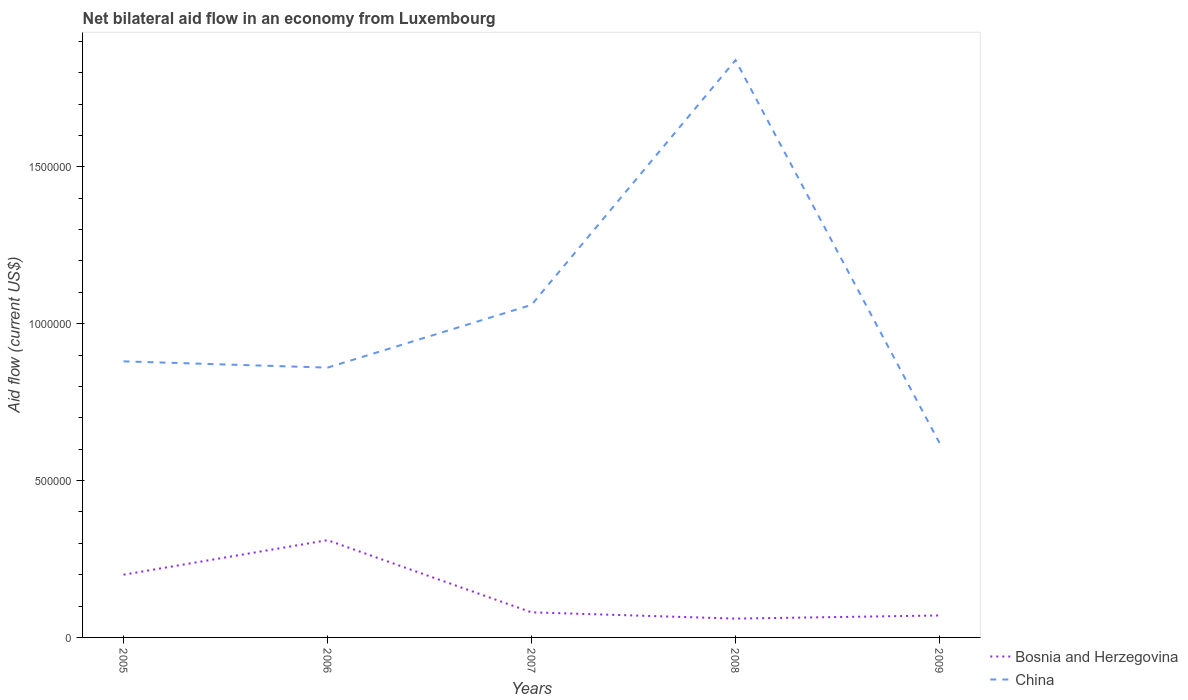How many different coloured lines are there?
Offer a terse response. 2. Across all years, what is the maximum net bilateral aid flow in China?
Your response must be concise. 6.20e+05. What is the total net bilateral aid flow in China in the graph?
Provide a short and direct response. 2.60e+05. What is the difference between the highest and the second highest net bilateral aid flow in Bosnia and Herzegovina?
Provide a succinct answer. 2.50e+05. How many lines are there?
Provide a succinct answer. 2. What is the difference between two consecutive major ticks on the Y-axis?
Make the answer very short. 5.00e+05. Are the values on the major ticks of Y-axis written in scientific E-notation?
Give a very brief answer. No. How are the legend labels stacked?
Offer a terse response. Vertical. What is the title of the graph?
Give a very brief answer. Net bilateral aid flow in an economy from Luxembourg. Does "Norway" appear as one of the legend labels in the graph?
Provide a short and direct response. No. What is the label or title of the X-axis?
Give a very brief answer. Years. What is the Aid flow (current US$) in China in 2005?
Keep it short and to the point. 8.80e+05. What is the Aid flow (current US$) of China in 2006?
Provide a short and direct response. 8.60e+05. What is the Aid flow (current US$) in Bosnia and Herzegovina in 2007?
Your response must be concise. 8.00e+04. What is the Aid flow (current US$) in China in 2007?
Offer a very short reply. 1.06e+06. What is the Aid flow (current US$) in China in 2008?
Your response must be concise. 1.84e+06. What is the Aid flow (current US$) in Bosnia and Herzegovina in 2009?
Provide a succinct answer. 7.00e+04. What is the Aid flow (current US$) of China in 2009?
Your answer should be very brief. 6.20e+05. Across all years, what is the maximum Aid flow (current US$) of Bosnia and Herzegovina?
Ensure brevity in your answer.  3.10e+05. Across all years, what is the maximum Aid flow (current US$) in China?
Your answer should be compact. 1.84e+06. Across all years, what is the minimum Aid flow (current US$) in Bosnia and Herzegovina?
Provide a succinct answer. 6.00e+04. Across all years, what is the minimum Aid flow (current US$) in China?
Offer a very short reply. 6.20e+05. What is the total Aid flow (current US$) of Bosnia and Herzegovina in the graph?
Give a very brief answer. 7.20e+05. What is the total Aid flow (current US$) of China in the graph?
Your answer should be very brief. 5.26e+06. What is the difference between the Aid flow (current US$) in Bosnia and Herzegovina in 2005 and that in 2008?
Give a very brief answer. 1.40e+05. What is the difference between the Aid flow (current US$) in China in 2005 and that in 2008?
Provide a short and direct response. -9.60e+05. What is the difference between the Aid flow (current US$) in Bosnia and Herzegovina in 2005 and that in 2009?
Provide a succinct answer. 1.30e+05. What is the difference between the Aid flow (current US$) in Bosnia and Herzegovina in 2006 and that in 2007?
Keep it short and to the point. 2.30e+05. What is the difference between the Aid flow (current US$) of China in 2006 and that in 2007?
Give a very brief answer. -2.00e+05. What is the difference between the Aid flow (current US$) of Bosnia and Herzegovina in 2006 and that in 2008?
Your answer should be compact. 2.50e+05. What is the difference between the Aid flow (current US$) of China in 2006 and that in 2008?
Offer a terse response. -9.80e+05. What is the difference between the Aid flow (current US$) of China in 2007 and that in 2008?
Your answer should be compact. -7.80e+05. What is the difference between the Aid flow (current US$) of Bosnia and Herzegovina in 2007 and that in 2009?
Your response must be concise. 10000. What is the difference between the Aid flow (current US$) in China in 2007 and that in 2009?
Make the answer very short. 4.40e+05. What is the difference between the Aid flow (current US$) of China in 2008 and that in 2009?
Provide a succinct answer. 1.22e+06. What is the difference between the Aid flow (current US$) of Bosnia and Herzegovina in 2005 and the Aid flow (current US$) of China in 2006?
Offer a terse response. -6.60e+05. What is the difference between the Aid flow (current US$) of Bosnia and Herzegovina in 2005 and the Aid flow (current US$) of China in 2007?
Make the answer very short. -8.60e+05. What is the difference between the Aid flow (current US$) in Bosnia and Herzegovina in 2005 and the Aid flow (current US$) in China in 2008?
Offer a very short reply. -1.64e+06. What is the difference between the Aid flow (current US$) in Bosnia and Herzegovina in 2005 and the Aid flow (current US$) in China in 2009?
Make the answer very short. -4.20e+05. What is the difference between the Aid flow (current US$) of Bosnia and Herzegovina in 2006 and the Aid flow (current US$) of China in 2007?
Provide a short and direct response. -7.50e+05. What is the difference between the Aid flow (current US$) of Bosnia and Herzegovina in 2006 and the Aid flow (current US$) of China in 2008?
Ensure brevity in your answer.  -1.53e+06. What is the difference between the Aid flow (current US$) in Bosnia and Herzegovina in 2006 and the Aid flow (current US$) in China in 2009?
Offer a terse response. -3.10e+05. What is the difference between the Aid flow (current US$) in Bosnia and Herzegovina in 2007 and the Aid flow (current US$) in China in 2008?
Ensure brevity in your answer.  -1.76e+06. What is the difference between the Aid flow (current US$) in Bosnia and Herzegovina in 2007 and the Aid flow (current US$) in China in 2009?
Give a very brief answer. -5.40e+05. What is the difference between the Aid flow (current US$) of Bosnia and Herzegovina in 2008 and the Aid flow (current US$) of China in 2009?
Give a very brief answer. -5.60e+05. What is the average Aid flow (current US$) in Bosnia and Herzegovina per year?
Your answer should be very brief. 1.44e+05. What is the average Aid flow (current US$) in China per year?
Your answer should be compact. 1.05e+06. In the year 2005, what is the difference between the Aid flow (current US$) of Bosnia and Herzegovina and Aid flow (current US$) of China?
Keep it short and to the point. -6.80e+05. In the year 2006, what is the difference between the Aid flow (current US$) of Bosnia and Herzegovina and Aid flow (current US$) of China?
Your response must be concise. -5.50e+05. In the year 2007, what is the difference between the Aid flow (current US$) in Bosnia and Herzegovina and Aid flow (current US$) in China?
Ensure brevity in your answer.  -9.80e+05. In the year 2008, what is the difference between the Aid flow (current US$) in Bosnia and Herzegovina and Aid flow (current US$) in China?
Provide a succinct answer. -1.78e+06. In the year 2009, what is the difference between the Aid flow (current US$) in Bosnia and Herzegovina and Aid flow (current US$) in China?
Keep it short and to the point. -5.50e+05. What is the ratio of the Aid flow (current US$) in Bosnia and Herzegovina in 2005 to that in 2006?
Give a very brief answer. 0.65. What is the ratio of the Aid flow (current US$) of China in 2005 to that in 2006?
Your response must be concise. 1.02. What is the ratio of the Aid flow (current US$) of China in 2005 to that in 2007?
Offer a terse response. 0.83. What is the ratio of the Aid flow (current US$) in Bosnia and Herzegovina in 2005 to that in 2008?
Ensure brevity in your answer.  3.33. What is the ratio of the Aid flow (current US$) of China in 2005 to that in 2008?
Your response must be concise. 0.48. What is the ratio of the Aid flow (current US$) of Bosnia and Herzegovina in 2005 to that in 2009?
Offer a very short reply. 2.86. What is the ratio of the Aid flow (current US$) of China in 2005 to that in 2009?
Your answer should be very brief. 1.42. What is the ratio of the Aid flow (current US$) in Bosnia and Herzegovina in 2006 to that in 2007?
Make the answer very short. 3.88. What is the ratio of the Aid flow (current US$) of China in 2006 to that in 2007?
Offer a terse response. 0.81. What is the ratio of the Aid flow (current US$) of Bosnia and Herzegovina in 2006 to that in 2008?
Keep it short and to the point. 5.17. What is the ratio of the Aid flow (current US$) of China in 2006 to that in 2008?
Provide a succinct answer. 0.47. What is the ratio of the Aid flow (current US$) of Bosnia and Herzegovina in 2006 to that in 2009?
Your response must be concise. 4.43. What is the ratio of the Aid flow (current US$) in China in 2006 to that in 2009?
Your answer should be compact. 1.39. What is the ratio of the Aid flow (current US$) in China in 2007 to that in 2008?
Provide a succinct answer. 0.58. What is the ratio of the Aid flow (current US$) of China in 2007 to that in 2009?
Offer a very short reply. 1.71. What is the ratio of the Aid flow (current US$) of China in 2008 to that in 2009?
Provide a succinct answer. 2.97. What is the difference between the highest and the second highest Aid flow (current US$) in China?
Your answer should be compact. 7.80e+05. What is the difference between the highest and the lowest Aid flow (current US$) of China?
Ensure brevity in your answer.  1.22e+06. 